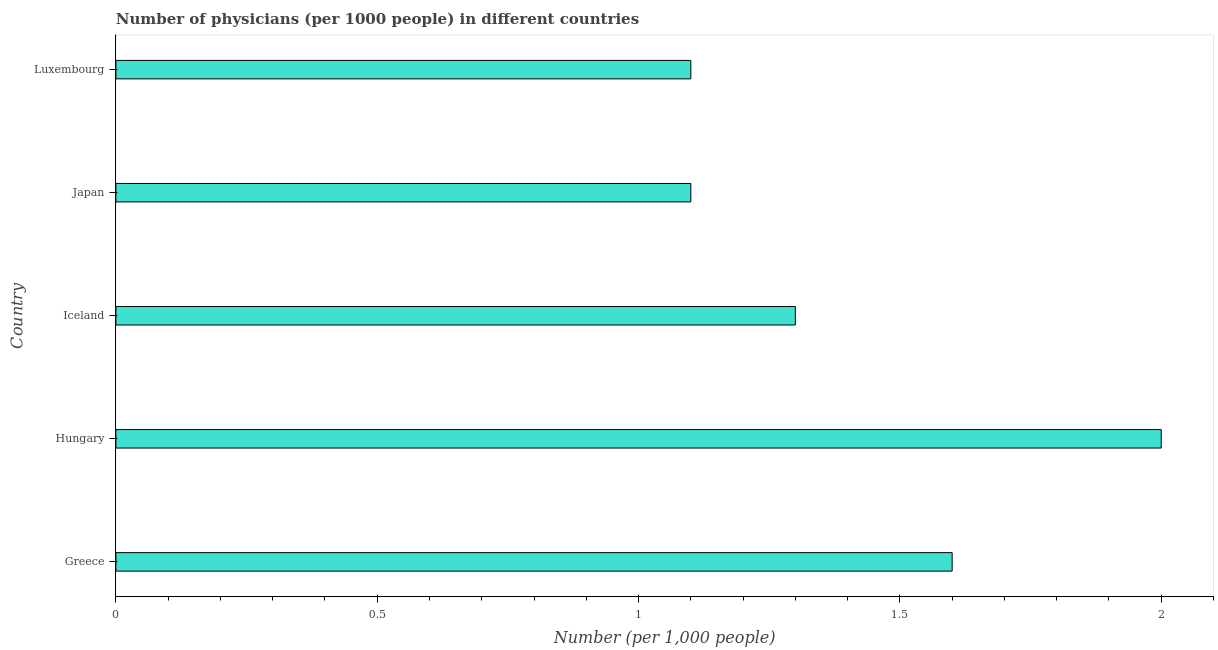What is the title of the graph?
Ensure brevity in your answer.  Number of physicians (per 1000 people) in different countries. What is the label or title of the X-axis?
Ensure brevity in your answer.  Number (per 1,0 people). What is the number of physicians in Iceland?
Provide a succinct answer. 1.3. Across all countries, what is the minimum number of physicians?
Give a very brief answer. 1.1. In which country was the number of physicians maximum?
Provide a succinct answer. Hungary. In which country was the number of physicians minimum?
Provide a short and direct response. Japan. What is the difference between the number of physicians in Hungary and Iceland?
Your answer should be very brief. 0.7. What is the average number of physicians per country?
Provide a short and direct response. 1.42. What is the ratio of the number of physicians in Greece to that in Hungary?
Provide a succinct answer. 0.8. Is the number of physicians in Greece less than that in Luxembourg?
Offer a very short reply. No. In how many countries, is the number of physicians greater than the average number of physicians taken over all countries?
Offer a terse response. 2. How many bars are there?
Your answer should be very brief. 5. Are all the bars in the graph horizontal?
Offer a very short reply. Yes. How many countries are there in the graph?
Provide a short and direct response. 5. Are the values on the major ticks of X-axis written in scientific E-notation?
Ensure brevity in your answer.  No. What is the Number (per 1,000 people) in Greece?
Your answer should be very brief. 1.6. What is the difference between the Number (per 1,000 people) in Greece and Hungary?
Keep it short and to the point. -0.4. What is the difference between the Number (per 1,000 people) in Greece and Iceland?
Your answer should be compact. 0.3. What is the difference between the Number (per 1,000 people) in Greece and Japan?
Offer a terse response. 0.5. What is the difference between the Number (per 1,000 people) in Japan and Luxembourg?
Your answer should be very brief. 0. What is the ratio of the Number (per 1,000 people) in Greece to that in Hungary?
Provide a succinct answer. 0.8. What is the ratio of the Number (per 1,000 people) in Greece to that in Iceland?
Your answer should be very brief. 1.23. What is the ratio of the Number (per 1,000 people) in Greece to that in Japan?
Your answer should be very brief. 1.46. What is the ratio of the Number (per 1,000 people) in Greece to that in Luxembourg?
Provide a short and direct response. 1.46. What is the ratio of the Number (per 1,000 people) in Hungary to that in Iceland?
Provide a short and direct response. 1.54. What is the ratio of the Number (per 1,000 people) in Hungary to that in Japan?
Ensure brevity in your answer.  1.82. What is the ratio of the Number (per 1,000 people) in Hungary to that in Luxembourg?
Provide a short and direct response. 1.82. What is the ratio of the Number (per 1,000 people) in Iceland to that in Japan?
Ensure brevity in your answer.  1.18. What is the ratio of the Number (per 1,000 people) in Iceland to that in Luxembourg?
Give a very brief answer. 1.18. 